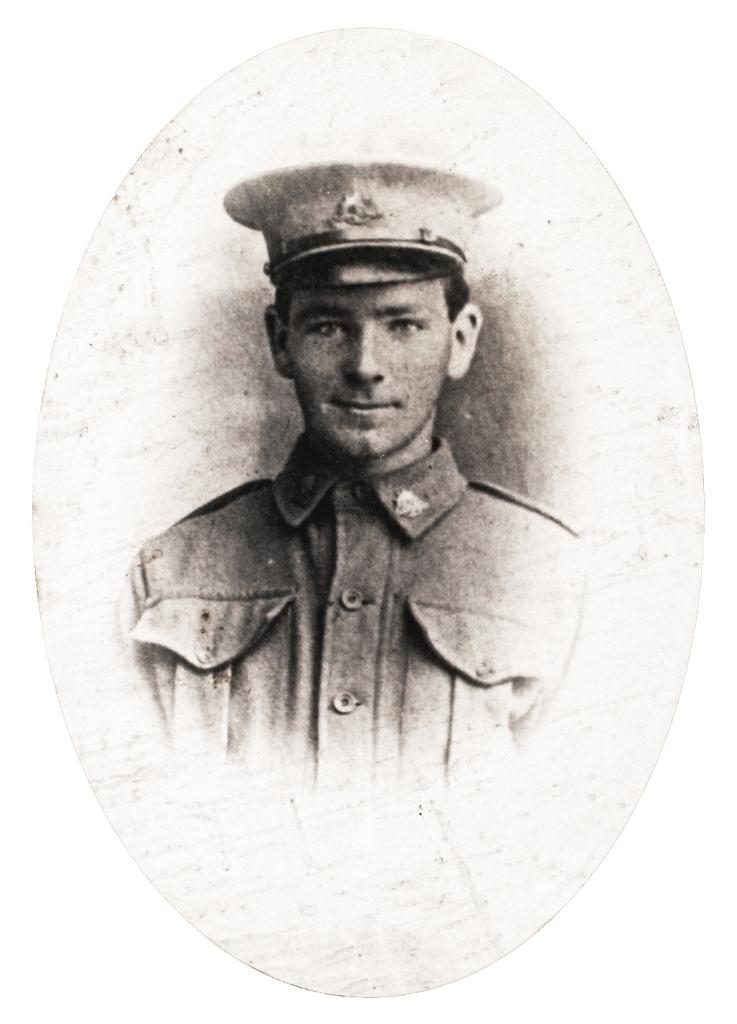What is the color scheme of the image? The image is black and white. Can you describe the main subject of the image? There is a man in the image. Where is the lumber located in the image? There is no lumber present in the image. What type of seat can be seen in the image? There is no seat present in the image. 